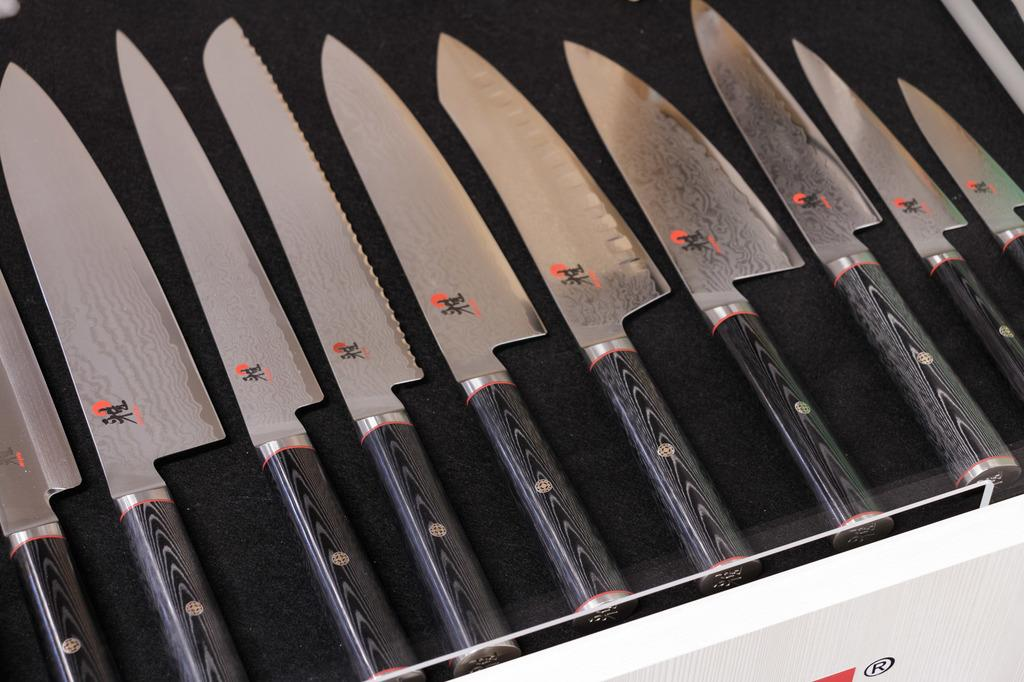What type of utensils are present in the image? There are knives in the image. How do the knives differ from one another? The knives have different shapes. Where are the knives located in the image? The knives are on a table. Can you see any arguments taking place through the window in the image? There is no window or argument present in the image; it only features knives on a table. 